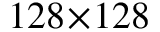Convert formula to latex. <formula><loc_0><loc_0><loc_500><loc_500>1 2 8 \, \times \, 1 2 8</formula> 